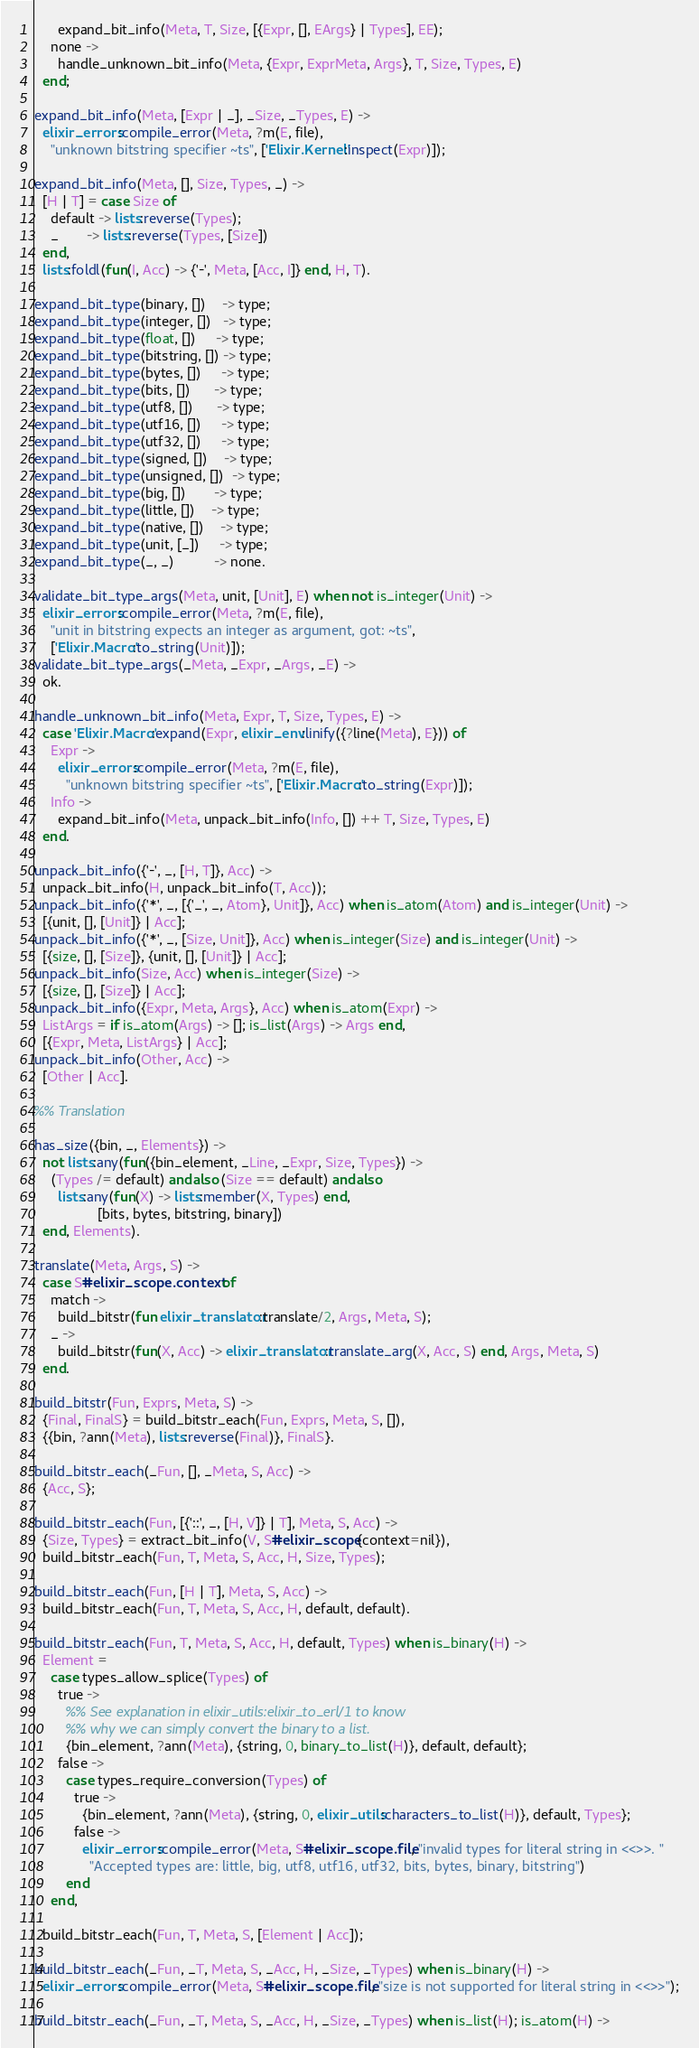<code> <loc_0><loc_0><loc_500><loc_500><_Erlang_>      expand_bit_info(Meta, T, Size, [{Expr, [], EArgs} | Types], EE);
    none ->
      handle_unknown_bit_info(Meta, {Expr, ExprMeta, Args}, T, Size, Types, E)
  end;

expand_bit_info(Meta, [Expr | _], _Size, _Types, E) ->
  elixir_errors:compile_error(Meta, ?m(E, file),
    "unknown bitstring specifier ~ts", ['Elixir.Kernel':inspect(Expr)]);

expand_bit_info(Meta, [], Size, Types, _) ->
  [H | T] = case Size of
    default -> lists:reverse(Types);
    _       -> lists:reverse(Types, [Size])
  end,
  lists:foldl(fun(I, Acc) -> {'-', Meta, [Acc, I]} end, H, T).

expand_bit_type(binary, [])    -> type;
expand_bit_type(integer, [])   -> type;
expand_bit_type(float, [])     -> type;
expand_bit_type(bitstring, []) -> type;
expand_bit_type(bytes, [])     -> type;
expand_bit_type(bits, [])      -> type;
expand_bit_type(utf8, [])      -> type;
expand_bit_type(utf16, [])     -> type;
expand_bit_type(utf32, [])     -> type;
expand_bit_type(signed, [])    -> type;
expand_bit_type(unsigned, [])  -> type;
expand_bit_type(big, [])       -> type;
expand_bit_type(little, [])    -> type;
expand_bit_type(native, [])    -> type;
expand_bit_type(unit, [_])     -> type;
expand_bit_type(_, _)          -> none.

validate_bit_type_args(Meta, unit, [Unit], E) when not is_integer(Unit) ->
  elixir_errors:compile_error(Meta, ?m(E, file),
    "unit in bitstring expects an integer as argument, got: ~ts",
    ['Elixir.Macro':to_string(Unit)]);
validate_bit_type_args(_Meta, _Expr, _Args, _E) ->
  ok.

handle_unknown_bit_info(Meta, Expr, T, Size, Types, E) ->
  case 'Elixir.Macro':expand(Expr, elixir_env:linify({?line(Meta), E})) of
    Expr ->
      elixir_errors:compile_error(Meta, ?m(E, file),
        "unknown bitstring specifier ~ts", ['Elixir.Macro':to_string(Expr)]);
    Info ->
      expand_bit_info(Meta, unpack_bit_info(Info, []) ++ T, Size, Types, E)
  end.

unpack_bit_info({'-', _, [H, T]}, Acc) ->
  unpack_bit_info(H, unpack_bit_info(T, Acc));
unpack_bit_info({'*', _, [{'_', _, Atom}, Unit]}, Acc) when is_atom(Atom) and is_integer(Unit) ->
  [{unit, [], [Unit]} | Acc];
unpack_bit_info({'*', _, [Size, Unit]}, Acc) when is_integer(Size) and is_integer(Unit) ->
  [{size, [], [Size]}, {unit, [], [Unit]} | Acc];
unpack_bit_info(Size, Acc) when is_integer(Size) ->
  [{size, [], [Size]} | Acc];
unpack_bit_info({Expr, Meta, Args}, Acc) when is_atom(Expr) ->
  ListArgs = if is_atom(Args) -> []; is_list(Args) -> Args end,
  [{Expr, Meta, ListArgs} | Acc];
unpack_bit_info(Other, Acc) ->
  [Other | Acc].

%% Translation

has_size({bin, _, Elements}) ->
  not lists:any(fun({bin_element, _Line, _Expr, Size, Types}) ->
    (Types /= default) andalso (Size == default) andalso
      lists:any(fun(X) -> lists:member(X, Types) end,
                [bits, bytes, bitstring, binary])
  end, Elements).

translate(Meta, Args, S) ->
  case S#elixir_scope.context of
    match ->
      build_bitstr(fun elixir_translator:translate/2, Args, Meta, S);
    _ ->
      build_bitstr(fun(X, Acc) -> elixir_translator:translate_arg(X, Acc, S) end, Args, Meta, S)
  end.

build_bitstr(Fun, Exprs, Meta, S) ->
  {Final, FinalS} = build_bitstr_each(Fun, Exprs, Meta, S, []),
  {{bin, ?ann(Meta), lists:reverse(Final)}, FinalS}.

build_bitstr_each(_Fun, [], _Meta, S, Acc) ->
  {Acc, S};

build_bitstr_each(Fun, [{'::', _, [H, V]} | T], Meta, S, Acc) ->
  {Size, Types} = extract_bit_info(V, S#elixir_scope{context=nil}),
  build_bitstr_each(Fun, T, Meta, S, Acc, H, Size, Types);

build_bitstr_each(Fun, [H | T], Meta, S, Acc) ->
  build_bitstr_each(Fun, T, Meta, S, Acc, H, default, default).

build_bitstr_each(Fun, T, Meta, S, Acc, H, default, Types) when is_binary(H) ->
  Element =
    case types_allow_splice(Types) of
      true ->
        %% See explanation in elixir_utils:elixir_to_erl/1 to know
        %% why we can simply convert the binary to a list.
        {bin_element, ?ann(Meta), {string, 0, binary_to_list(H)}, default, default};
      false ->
        case types_require_conversion(Types) of
          true ->
            {bin_element, ?ann(Meta), {string, 0, elixir_utils:characters_to_list(H)}, default, Types};
          false ->
            elixir_errors:compile_error(Meta, S#elixir_scope.file, "invalid types for literal string in <<>>. "
              "Accepted types are: little, big, utf8, utf16, utf32, bits, bytes, binary, bitstring")
        end
    end,

  build_bitstr_each(Fun, T, Meta, S, [Element | Acc]);

build_bitstr_each(_Fun, _T, Meta, S, _Acc, H, _Size, _Types) when is_binary(H) ->
  elixir_errors:compile_error(Meta, S#elixir_scope.file, "size is not supported for literal string in <<>>");

build_bitstr_each(_Fun, _T, Meta, S, _Acc, H, _Size, _Types) when is_list(H); is_atom(H) -></code> 